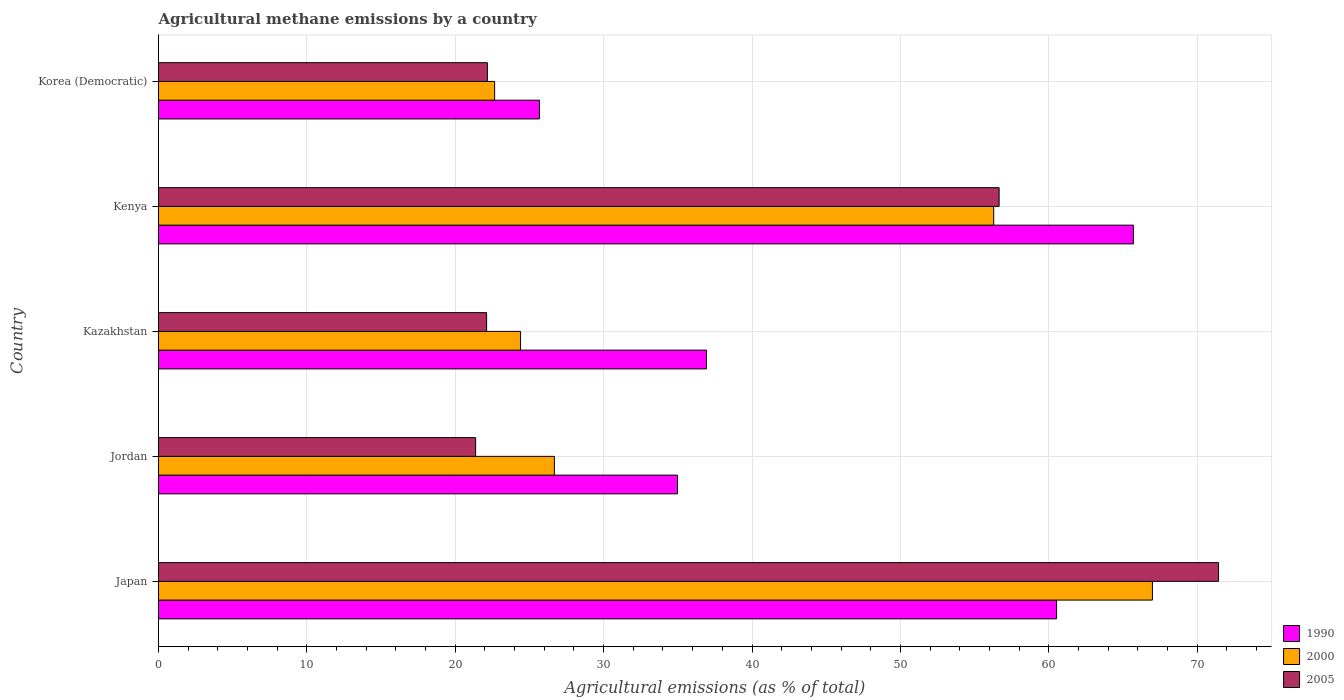How many different coloured bars are there?
Your response must be concise. 3. Are the number of bars per tick equal to the number of legend labels?
Make the answer very short. Yes. What is the label of the 4th group of bars from the top?
Your answer should be very brief. Jordan. In how many cases, is the number of bars for a given country not equal to the number of legend labels?
Make the answer very short. 0. What is the amount of agricultural methane emitted in 2000 in Japan?
Offer a very short reply. 66.99. Across all countries, what is the maximum amount of agricultural methane emitted in 2005?
Your response must be concise. 71.44. Across all countries, what is the minimum amount of agricultural methane emitted in 2000?
Your answer should be compact. 22.65. In which country was the amount of agricultural methane emitted in 2000 maximum?
Keep it short and to the point. Japan. In which country was the amount of agricultural methane emitted in 2005 minimum?
Offer a terse response. Jordan. What is the total amount of agricultural methane emitted in 2005 in the graph?
Ensure brevity in your answer.  193.75. What is the difference between the amount of agricultural methane emitted in 2005 in Japan and that in Kenya?
Your answer should be compact. 14.79. What is the difference between the amount of agricultural methane emitted in 2005 in Korea (Democratic) and the amount of agricultural methane emitted in 2000 in Kazakhstan?
Offer a terse response. -2.24. What is the average amount of agricultural methane emitted in 1990 per country?
Offer a terse response. 44.76. What is the difference between the amount of agricultural methane emitted in 2005 and amount of agricultural methane emitted in 1990 in Jordan?
Provide a succinct answer. -13.61. In how many countries, is the amount of agricultural methane emitted in 2000 greater than 24 %?
Your answer should be very brief. 4. What is the ratio of the amount of agricultural methane emitted in 2000 in Japan to that in Korea (Democratic)?
Give a very brief answer. 2.96. What is the difference between the highest and the second highest amount of agricultural methane emitted in 1990?
Offer a very short reply. 5.18. What is the difference between the highest and the lowest amount of agricultural methane emitted in 2005?
Keep it short and to the point. 50.07. In how many countries, is the amount of agricultural methane emitted in 2005 greater than the average amount of agricultural methane emitted in 2005 taken over all countries?
Provide a succinct answer. 2. What does the 3rd bar from the top in Kazakhstan represents?
Your answer should be very brief. 1990. What does the 2nd bar from the bottom in Korea (Democratic) represents?
Your answer should be compact. 2000. Are all the bars in the graph horizontal?
Make the answer very short. Yes. How many countries are there in the graph?
Offer a very short reply. 5. What is the difference between two consecutive major ticks on the X-axis?
Offer a terse response. 10. Does the graph contain any zero values?
Your response must be concise. No. Does the graph contain grids?
Give a very brief answer. Yes. How are the legend labels stacked?
Provide a short and direct response. Vertical. What is the title of the graph?
Your answer should be very brief. Agricultural methane emissions by a country. What is the label or title of the X-axis?
Offer a very short reply. Agricultural emissions (as % of total). What is the Agricultural emissions (as % of total) in 1990 in Japan?
Keep it short and to the point. 60.53. What is the Agricultural emissions (as % of total) in 2000 in Japan?
Offer a terse response. 66.99. What is the Agricultural emissions (as % of total) of 2005 in Japan?
Ensure brevity in your answer.  71.44. What is the Agricultural emissions (as % of total) in 1990 in Jordan?
Keep it short and to the point. 34.98. What is the Agricultural emissions (as % of total) in 2000 in Jordan?
Provide a short and direct response. 26.68. What is the Agricultural emissions (as % of total) in 2005 in Jordan?
Provide a short and direct response. 21.37. What is the Agricultural emissions (as % of total) in 1990 in Kazakhstan?
Provide a succinct answer. 36.93. What is the Agricultural emissions (as % of total) of 2000 in Kazakhstan?
Provide a succinct answer. 24.4. What is the Agricultural emissions (as % of total) in 2005 in Kazakhstan?
Your response must be concise. 22.11. What is the Agricultural emissions (as % of total) of 1990 in Kenya?
Provide a succinct answer. 65.71. What is the Agricultural emissions (as % of total) in 2000 in Kenya?
Offer a terse response. 56.29. What is the Agricultural emissions (as % of total) of 2005 in Kenya?
Make the answer very short. 56.66. What is the Agricultural emissions (as % of total) in 1990 in Korea (Democratic)?
Offer a terse response. 25.68. What is the Agricultural emissions (as % of total) in 2000 in Korea (Democratic)?
Keep it short and to the point. 22.65. What is the Agricultural emissions (as % of total) in 2005 in Korea (Democratic)?
Keep it short and to the point. 22.16. Across all countries, what is the maximum Agricultural emissions (as % of total) in 1990?
Give a very brief answer. 65.71. Across all countries, what is the maximum Agricultural emissions (as % of total) of 2000?
Provide a short and direct response. 66.99. Across all countries, what is the maximum Agricultural emissions (as % of total) in 2005?
Give a very brief answer. 71.44. Across all countries, what is the minimum Agricultural emissions (as % of total) of 1990?
Ensure brevity in your answer.  25.68. Across all countries, what is the minimum Agricultural emissions (as % of total) of 2000?
Offer a terse response. 22.65. Across all countries, what is the minimum Agricultural emissions (as % of total) of 2005?
Offer a very short reply. 21.37. What is the total Agricultural emissions (as % of total) in 1990 in the graph?
Make the answer very short. 223.82. What is the total Agricultural emissions (as % of total) in 2000 in the graph?
Provide a short and direct response. 197.01. What is the total Agricultural emissions (as % of total) of 2005 in the graph?
Your answer should be very brief. 193.75. What is the difference between the Agricultural emissions (as % of total) of 1990 in Japan and that in Jordan?
Keep it short and to the point. 25.55. What is the difference between the Agricultural emissions (as % of total) of 2000 in Japan and that in Jordan?
Offer a terse response. 40.31. What is the difference between the Agricultural emissions (as % of total) in 2005 in Japan and that in Jordan?
Provide a succinct answer. 50.07. What is the difference between the Agricultural emissions (as % of total) in 1990 in Japan and that in Kazakhstan?
Offer a terse response. 23.6. What is the difference between the Agricultural emissions (as % of total) in 2000 in Japan and that in Kazakhstan?
Your answer should be very brief. 42.59. What is the difference between the Agricultural emissions (as % of total) in 2005 in Japan and that in Kazakhstan?
Offer a terse response. 49.33. What is the difference between the Agricultural emissions (as % of total) in 1990 in Japan and that in Kenya?
Provide a short and direct response. -5.18. What is the difference between the Agricultural emissions (as % of total) in 2000 in Japan and that in Kenya?
Your response must be concise. 10.7. What is the difference between the Agricultural emissions (as % of total) of 2005 in Japan and that in Kenya?
Keep it short and to the point. 14.79. What is the difference between the Agricultural emissions (as % of total) of 1990 in Japan and that in Korea (Democratic)?
Your response must be concise. 34.85. What is the difference between the Agricultural emissions (as % of total) of 2000 in Japan and that in Korea (Democratic)?
Make the answer very short. 44.34. What is the difference between the Agricultural emissions (as % of total) of 2005 in Japan and that in Korea (Democratic)?
Offer a terse response. 49.28. What is the difference between the Agricultural emissions (as % of total) in 1990 in Jordan and that in Kazakhstan?
Give a very brief answer. -1.95. What is the difference between the Agricultural emissions (as % of total) in 2000 in Jordan and that in Kazakhstan?
Give a very brief answer. 2.28. What is the difference between the Agricultural emissions (as % of total) of 2005 in Jordan and that in Kazakhstan?
Provide a short and direct response. -0.74. What is the difference between the Agricultural emissions (as % of total) in 1990 in Jordan and that in Kenya?
Provide a succinct answer. -30.73. What is the difference between the Agricultural emissions (as % of total) in 2000 in Jordan and that in Kenya?
Your answer should be very brief. -29.61. What is the difference between the Agricultural emissions (as % of total) in 2005 in Jordan and that in Kenya?
Keep it short and to the point. -35.28. What is the difference between the Agricultural emissions (as % of total) of 1990 in Jordan and that in Korea (Democratic)?
Offer a very short reply. 9.3. What is the difference between the Agricultural emissions (as % of total) in 2000 in Jordan and that in Korea (Democratic)?
Keep it short and to the point. 4.03. What is the difference between the Agricultural emissions (as % of total) of 2005 in Jordan and that in Korea (Democratic)?
Your answer should be very brief. -0.79. What is the difference between the Agricultural emissions (as % of total) of 1990 in Kazakhstan and that in Kenya?
Your answer should be very brief. -28.78. What is the difference between the Agricultural emissions (as % of total) in 2000 in Kazakhstan and that in Kenya?
Keep it short and to the point. -31.89. What is the difference between the Agricultural emissions (as % of total) of 2005 in Kazakhstan and that in Kenya?
Offer a very short reply. -34.54. What is the difference between the Agricultural emissions (as % of total) of 1990 in Kazakhstan and that in Korea (Democratic)?
Your answer should be very brief. 11.25. What is the difference between the Agricultural emissions (as % of total) of 2000 in Kazakhstan and that in Korea (Democratic)?
Your answer should be compact. 1.75. What is the difference between the Agricultural emissions (as % of total) in 2005 in Kazakhstan and that in Korea (Democratic)?
Give a very brief answer. -0.05. What is the difference between the Agricultural emissions (as % of total) in 1990 in Kenya and that in Korea (Democratic)?
Ensure brevity in your answer.  40.03. What is the difference between the Agricultural emissions (as % of total) of 2000 in Kenya and that in Korea (Democratic)?
Keep it short and to the point. 33.64. What is the difference between the Agricultural emissions (as % of total) of 2005 in Kenya and that in Korea (Democratic)?
Your answer should be compact. 34.49. What is the difference between the Agricultural emissions (as % of total) of 1990 in Japan and the Agricultural emissions (as % of total) of 2000 in Jordan?
Ensure brevity in your answer.  33.85. What is the difference between the Agricultural emissions (as % of total) of 1990 in Japan and the Agricultural emissions (as % of total) of 2005 in Jordan?
Make the answer very short. 39.15. What is the difference between the Agricultural emissions (as % of total) of 2000 in Japan and the Agricultural emissions (as % of total) of 2005 in Jordan?
Keep it short and to the point. 45.62. What is the difference between the Agricultural emissions (as % of total) of 1990 in Japan and the Agricultural emissions (as % of total) of 2000 in Kazakhstan?
Keep it short and to the point. 36.13. What is the difference between the Agricultural emissions (as % of total) of 1990 in Japan and the Agricultural emissions (as % of total) of 2005 in Kazakhstan?
Ensure brevity in your answer.  38.41. What is the difference between the Agricultural emissions (as % of total) of 2000 in Japan and the Agricultural emissions (as % of total) of 2005 in Kazakhstan?
Your answer should be very brief. 44.88. What is the difference between the Agricultural emissions (as % of total) in 1990 in Japan and the Agricultural emissions (as % of total) in 2000 in Kenya?
Your answer should be compact. 4.24. What is the difference between the Agricultural emissions (as % of total) in 1990 in Japan and the Agricultural emissions (as % of total) in 2005 in Kenya?
Give a very brief answer. 3.87. What is the difference between the Agricultural emissions (as % of total) in 2000 in Japan and the Agricultural emissions (as % of total) in 2005 in Kenya?
Your answer should be compact. 10.33. What is the difference between the Agricultural emissions (as % of total) of 1990 in Japan and the Agricultural emissions (as % of total) of 2000 in Korea (Democratic)?
Keep it short and to the point. 37.87. What is the difference between the Agricultural emissions (as % of total) in 1990 in Japan and the Agricultural emissions (as % of total) in 2005 in Korea (Democratic)?
Keep it short and to the point. 38.36. What is the difference between the Agricultural emissions (as % of total) in 2000 in Japan and the Agricultural emissions (as % of total) in 2005 in Korea (Democratic)?
Offer a very short reply. 44.82. What is the difference between the Agricultural emissions (as % of total) in 1990 in Jordan and the Agricultural emissions (as % of total) in 2000 in Kazakhstan?
Provide a succinct answer. 10.58. What is the difference between the Agricultural emissions (as % of total) in 1990 in Jordan and the Agricultural emissions (as % of total) in 2005 in Kazakhstan?
Your answer should be compact. 12.87. What is the difference between the Agricultural emissions (as % of total) of 2000 in Jordan and the Agricultural emissions (as % of total) of 2005 in Kazakhstan?
Offer a terse response. 4.57. What is the difference between the Agricultural emissions (as % of total) of 1990 in Jordan and the Agricultural emissions (as % of total) of 2000 in Kenya?
Your answer should be compact. -21.31. What is the difference between the Agricultural emissions (as % of total) in 1990 in Jordan and the Agricultural emissions (as % of total) in 2005 in Kenya?
Your response must be concise. -21.68. What is the difference between the Agricultural emissions (as % of total) of 2000 in Jordan and the Agricultural emissions (as % of total) of 2005 in Kenya?
Make the answer very short. -29.98. What is the difference between the Agricultural emissions (as % of total) in 1990 in Jordan and the Agricultural emissions (as % of total) in 2000 in Korea (Democratic)?
Offer a terse response. 12.32. What is the difference between the Agricultural emissions (as % of total) in 1990 in Jordan and the Agricultural emissions (as % of total) in 2005 in Korea (Democratic)?
Your answer should be compact. 12.81. What is the difference between the Agricultural emissions (as % of total) in 2000 in Jordan and the Agricultural emissions (as % of total) in 2005 in Korea (Democratic)?
Make the answer very short. 4.52. What is the difference between the Agricultural emissions (as % of total) of 1990 in Kazakhstan and the Agricultural emissions (as % of total) of 2000 in Kenya?
Your answer should be compact. -19.36. What is the difference between the Agricultural emissions (as % of total) of 1990 in Kazakhstan and the Agricultural emissions (as % of total) of 2005 in Kenya?
Provide a succinct answer. -19.73. What is the difference between the Agricultural emissions (as % of total) of 2000 in Kazakhstan and the Agricultural emissions (as % of total) of 2005 in Kenya?
Offer a very short reply. -32.25. What is the difference between the Agricultural emissions (as % of total) in 1990 in Kazakhstan and the Agricultural emissions (as % of total) in 2000 in Korea (Democratic)?
Keep it short and to the point. 14.27. What is the difference between the Agricultural emissions (as % of total) in 1990 in Kazakhstan and the Agricultural emissions (as % of total) in 2005 in Korea (Democratic)?
Provide a succinct answer. 14.76. What is the difference between the Agricultural emissions (as % of total) of 2000 in Kazakhstan and the Agricultural emissions (as % of total) of 2005 in Korea (Democratic)?
Give a very brief answer. 2.24. What is the difference between the Agricultural emissions (as % of total) in 1990 in Kenya and the Agricultural emissions (as % of total) in 2000 in Korea (Democratic)?
Your answer should be compact. 43.05. What is the difference between the Agricultural emissions (as % of total) in 1990 in Kenya and the Agricultural emissions (as % of total) in 2005 in Korea (Democratic)?
Your answer should be very brief. 43.54. What is the difference between the Agricultural emissions (as % of total) in 2000 in Kenya and the Agricultural emissions (as % of total) in 2005 in Korea (Democratic)?
Your response must be concise. 34.13. What is the average Agricultural emissions (as % of total) of 1990 per country?
Ensure brevity in your answer.  44.76. What is the average Agricultural emissions (as % of total) in 2000 per country?
Your response must be concise. 39.4. What is the average Agricultural emissions (as % of total) in 2005 per country?
Provide a succinct answer. 38.75. What is the difference between the Agricultural emissions (as % of total) in 1990 and Agricultural emissions (as % of total) in 2000 in Japan?
Provide a short and direct response. -6.46. What is the difference between the Agricultural emissions (as % of total) in 1990 and Agricultural emissions (as % of total) in 2005 in Japan?
Your answer should be compact. -10.92. What is the difference between the Agricultural emissions (as % of total) of 2000 and Agricultural emissions (as % of total) of 2005 in Japan?
Make the answer very short. -4.46. What is the difference between the Agricultural emissions (as % of total) in 1990 and Agricultural emissions (as % of total) in 2000 in Jordan?
Ensure brevity in your answer.  8.3. What is the difference between the Agricultural emissions (as % of total) of 1990 and Agricultural emissions (as % of total) of 2005 in Jordan?
Your response must be concise. 13.61. What is the difference between the Agricultural emissions (as % of total) of 2000 and Agricultural emissions (as % of total) of 2005 in Jordan?
Offer a very short reply. 5.31. What is the difference between the Agricultural emissions (as % of total) in 1990 and Agricultural emissions (as % of total) in 2000 in Kazakhstan?
Provide a short and direct response. 12.53. What is the difference between the Agricultural emissions (as % of total) in 1990 and Agricultural emissions (as % of total) in 2005 in Kazakhstan?
Your answer should be compact. 14.82. What is the difference between the Agricultural emissions (as % of total) of 2000 and Agricultural emissions (as % of total) of 2005 in Kazakhstan?
Provide a succinct answer. 2.29. What is the difference between the Agricultural emissions (as % of total) in 1990 and Agricultural emissions (as % of total) in 2000 in Kenya?
Your response must be concise. 9.42. What is the difference between the Agricultural emissions (as % of total) of 1990 and Agricultural emissions (as % of total) of 2005 in Kenya?
Offer a terse response. 9.05. What is the difference between the Agricultural emissions (as % of total) of 2000 and Agricultural emissions (as % of total) of 2005 in Kenya?
Offer a very short reply. -0.37. What is the difference between the Agricultural emissions (as % of total) of 1990 and Agricultural emissions (as % of total) of 2000 in Korea (Democratic)?
Offer a very short reply. 3.02. What is the difference between the Agricultural emissions (as % of total) of 1990 and Agricultural emissions (as % of total) of 2005 in Korea (Democratic)?
Your answer should be very brief. 3.51. What is the difference between the Agricultural emissions (as % of total) in 2000 and Agricultural emissions (as % of total) in 2005 in Korea (Democratic)?
Give a very brief answer. 0.49. What is the ratio of the Agricultural emissions (as % of total) of 1990 in Japan to that in Jordan?
Offer a very short reply. 1.73. What is the ratio of the Agricultural emissions (as % of total) of 2000 in Japan to that in Jordan?
Your answer should be very brief. 2.51. What is the ratio of the Agricultural emissions (as % of total) of 2005 in Japan to that in Jordan?
Offer a very short reply. 3.34. What is the ratio of the Agricultural emissions (as % of total) in 1990 in Japan to that in Kazakhstan?
Offer a terse response. 1.64. What is the ratio of the Agricultural emissions (as % of total) of 2000 in Japan to that in Kazakhstan?
Make the answer very short. 2.75. What is the ratio of the Agricultural emissions (as % of total) in 2005 in Japan to that in Kazakhstan?
Your answer should be compact. 3.23. What is the ratio of the Agricultural emissions (as % of total) in 1990 in Japan to that in Kenya?
Provide a succinct answer. 0.92. What is the ratio of the Agricultural emissions (as % of total) in 2000 in Japan to that in Kenya?
Your answer should be very brief. 1.19. What is the ratio of the Agricultural emissions (as % of total) of 2005 in Japan to that in Kenya?
Your response must be concise. 1.26. What is the ratio of the Agricultural emissions (as % of total) of 1990 in Japan to that in Korea (Democratic)?
Keep it short and to the point. 2.36. What is the ratio of the Agricultural emissions (as % of total) in 2000 in Japan to that in Korea (Democratic)?
Give a very brief answer. 2.96. What is the ratio of the Agricultural emissions (as % of total) in 2005 in Japan to that in Korea (Democratic)?
Offer a terse response. 3.22. What is the ratio of the Agricultural emissions (as % of total) of 1990 in Jordan to that in Kazakhstan?
Your response must be concise. 0.95. What is the ratio of the Agricultural emissions (as % of total) of 2000 in Jordan to that in Kazakhstan?
Make the answer very short. 1.09. What is the ratio of the Agricultural emissions (as % of total) in 2005 in Jordan to that in Kazakhstan?
Provide a succinct answer. 0.97. What is the ratio of the Agricultural emissions (as % of total) of 1990 in Jordan to that in Kenya?
Your answer should be compact. 0.53. What is the ratio of the Agricultural emissions (as % of total) in 2000 in Jordan to that in Kenya?
Provide a short and direct response. 0.47. What is the ratio of the Agricultural emissions (as % of total) of 2005 in Jordan to that in Kenya?
Offer a terse response. 0.38. What is the ratio of the Agricultural emissions (as % of total) of 1990 in Jordan to that in Korea (Democratic)?
Your answer should be very brief. 1.36. What is the ratio of the Agricultural emissions (as % of total) in 2000 in Jordan to that in Korea (Democratic)?
Provide a short and direct response. 1.18. What is the ratio of the Agricultural emissions (as % of total) in 2005 in Jordan to that in Korea (Democratic)?
Your answer should be compact. 0.96. What is the ratio of the Agricultural emissions (as % of total) in 1990 in Kazakhstan to that in Kenya?
Offer a very short reply. 0.56. What is the ratio of the Agricultural emissions (as % of total) in 2000 in Kazakhstan to that in Kenya?
Your answer should be very brief. 0.43. What is the ratio of the Agricultural emissions (as % of total) in 2005 in Kazakhstan to that in Kenya?
Offer a very short reply. 0.39. What is the ratio of the Agricultural emissions (as % of total) of 1990 in Kazakhstan to that in Korea (Democratic)?
Give a very brief answer. 1.44. What is the ratio of the Agricultural emissions (as % of total) of 2000 in Kazakhstan to that in Korea (Democratic)?
Your answer should be compact. 1.08. What is the ratio of the Agricultural emissions (as % of total) in 2005 in Kazakhstan to that in Korea (Democratic)?
Provide a short and direct response. 1. What is the ratio of the Agricultural emissions (as % of total) in 1990 in Kenya to that in Korea (Democratic)?
Offer a very short reply. 2.56. What is the ratio of the Agricultural emissions (as % of total) in 2000 in Kenya to that in Korea (Democratic)?
Your answer should be very brief. 2.48. What is the ratio of the Agricultural emissions (as % of total) of 2005 in Kenya to that in Korea (Democratic)?
Your answer should be very brief. 2.56. What is the difference between the highest and the second highest Agricultural emissions (as % of total) of 1990?
Keep it short and to the point. 5.18. What is the difference between the highest and the second highest Agricultural emissions (as % of total) of 2000?
Your response must be concise. 10.7. What is the difference between the highest and the second highest Agricultural emissions (as % of total) of 2005?
Ensure brevity in your answer.  14.79. What is the difference between the highest and the lowest Agricultural emissions (as % of total) of 1990?
Provide a succinct answer. 40.03. What is the difference between the highest and the lowest Agricultural emissions (as % of total) of 2000?
Your answer should be compact. 44.34. What is the difference between the highest and the lowest Agricultural emissions (as % of total) in 2005?
Offer a terse response. 50.07. 